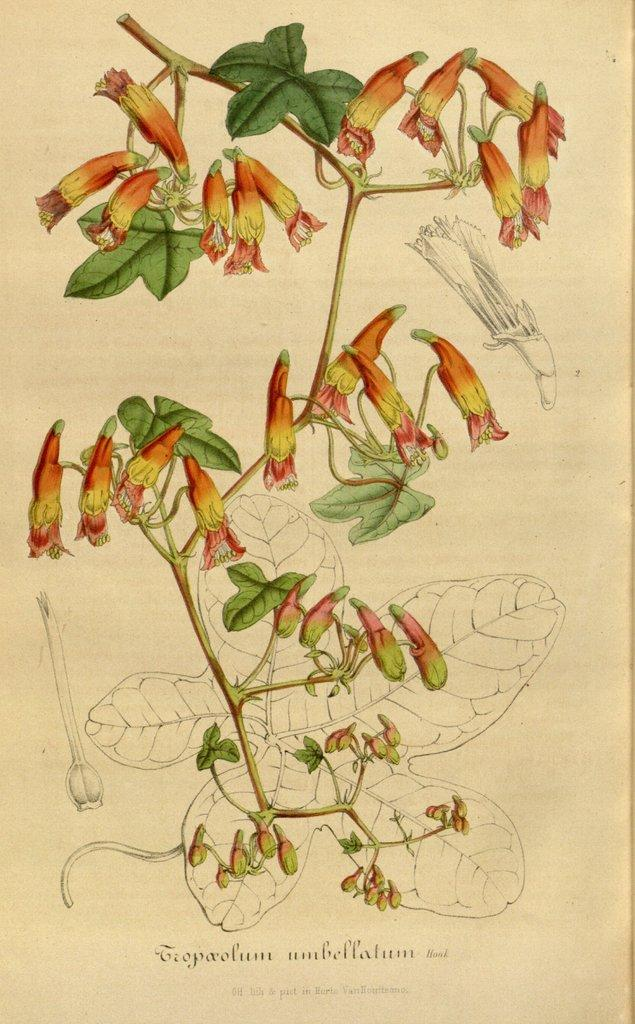What is depicted in the image? There is a drawing in the image. What else can be seen on the image besides the drawing? There is writing on the image. What type of furniture is depicted in the drawing? There is no furniture depicted in the drawing, as the facts provided do not mention any furniture. 